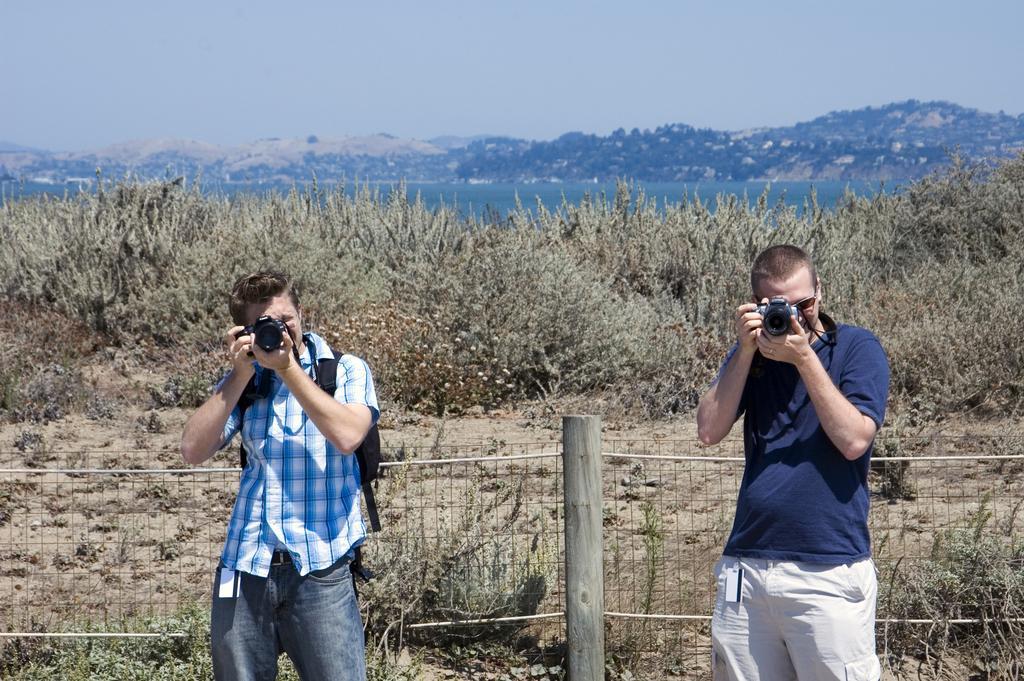In one or two sentences, can you explain what this image depicts? In this image we can see the mountains, one like, some trees, plants, bushes and some grass on the surface. There are two persons standing and taking photos with the camera. One blue check shirt man wearing bag, on wooden pole with fence and at the top there is the sky. 